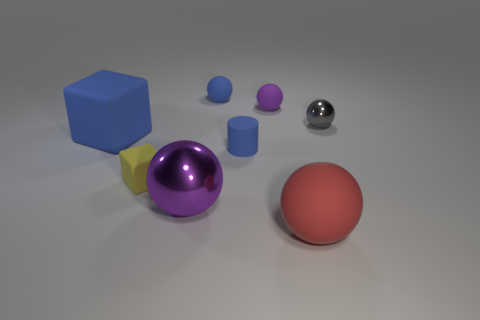There is a metal sphere that is behind the large sphere behind the large red matte sphere; what is its size? The metal sphere appears to be relatively small in comparison to the other objects present in the image. Specifically, it seems to be slightly larger than the smallest spheres in the scene but significantly smaller than the large red matte sphere. 